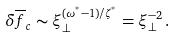Convert formula to latex. <formula><loc_0><loc_0><loc_500><loc_500>\delta \overline { f } _ { c } \sim \xi _ { \perp } ^ { ( \omega ^ { ^ { * } } - 1 ) / \zeta ^ { ^ { * } } } = \xi _ { \perp } ^ { - 2 } \, .</formula> 